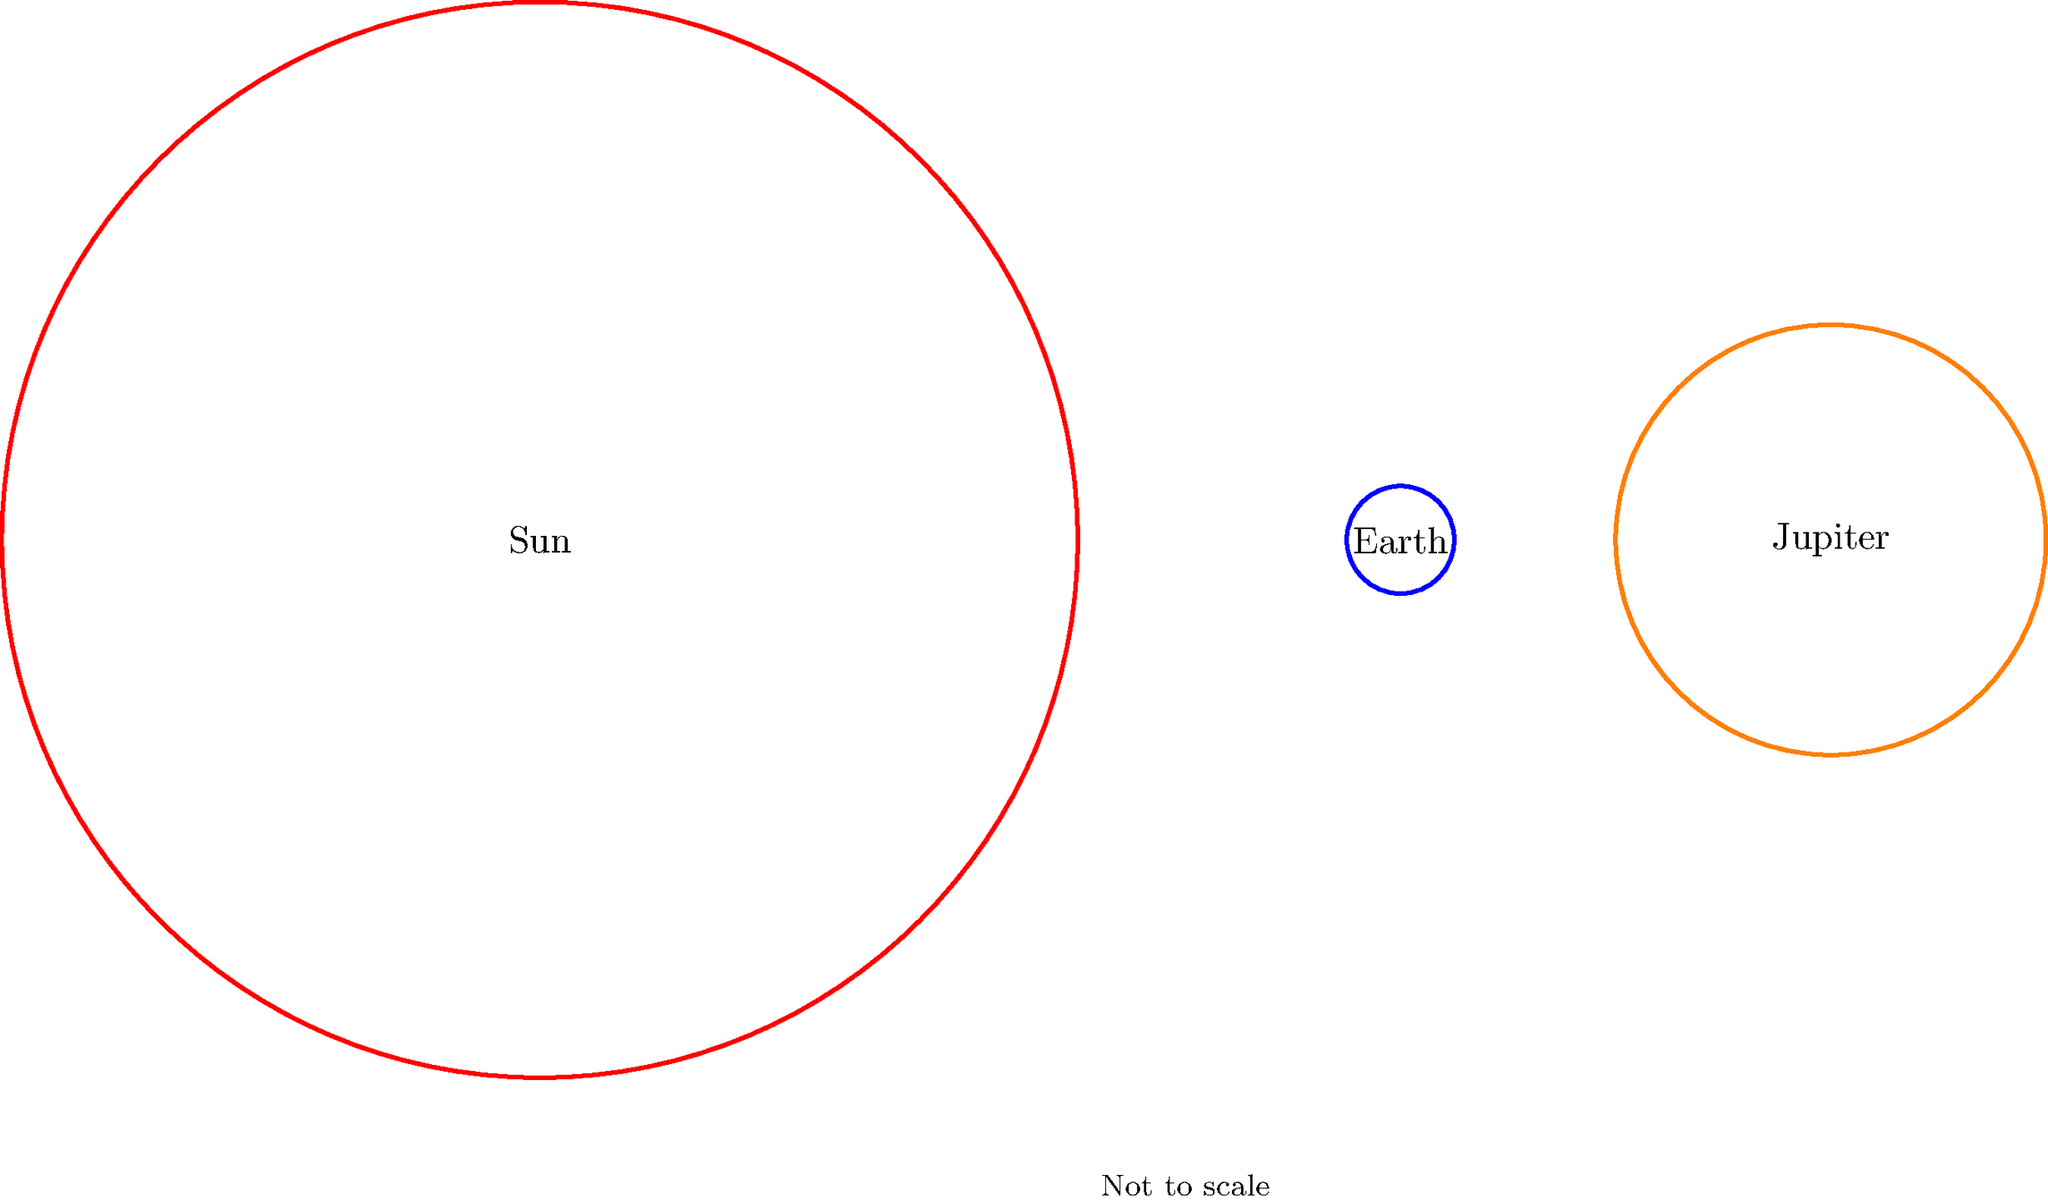In the diagram above, which shows the relative sizes of the Sun, Earth, and Jupiter (not to scale), approximately how many times larger is the diameter of Jupiter compared to the diameter of Earth? To determine how many times larger Jupiter's diameter is compared to Earth's, we need to follow these steps:

1. Observe the relative sizes of the circles representing Earth and Jupiter.
2. Estimate the ratio of their diameters based on the visual representation.
3. In the diagram, we can see that Jupiter's circle is significantly larger than Earth's.
4. Measuring or estimating from the image, we can see that Jupiter's diameter is about 4 times larger than Earth's.
5. This visual representation is fairly accurate to reality. In fact, Jupiter's equatorial diameter is about 11 times that of Earth's, but for the purposes of this simplified diagram, we can estimate it as 4 times larger.

It's important to note that while this diagram gives us a general idea of the size differences, it's not to scale. In reality, the size differences between these celestial bodies are much more extreme.

This kind of comparative visualization can help students understand relative sizes in astronomy, which can be difficult to grasp due to the enormous scale differences involved.
Answer: Approximately 4 times larger 